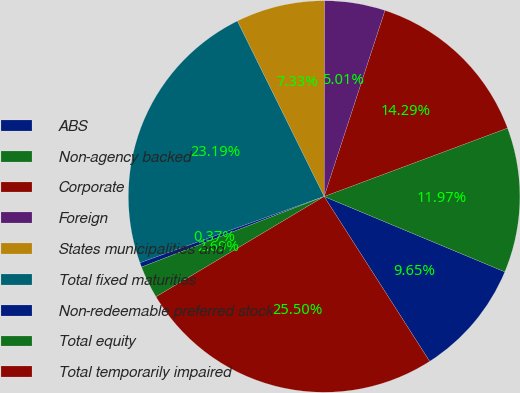Convert chart to OTSL. <chart><loc_0><loc_0><loc_500><loc_500><pie_chart><fcel>ABS<fcel>Non-agency backed<fcel>Corporate<fcel>Foreign<fcel>States municipalities and<fcel>Total fixed maturities<fcel>Non-redeemable preferred stock<fcel>Total equity<fcel>Total temporarily impaired<nl><fcel>9.65%<fcel>11.97%<fcel>14.29%<fcel>5.01%<fcel>7.33%<fcel>23.19%<fcel>0.37%<fcel>2.69%<fcel>25.5%<nl></chart> 